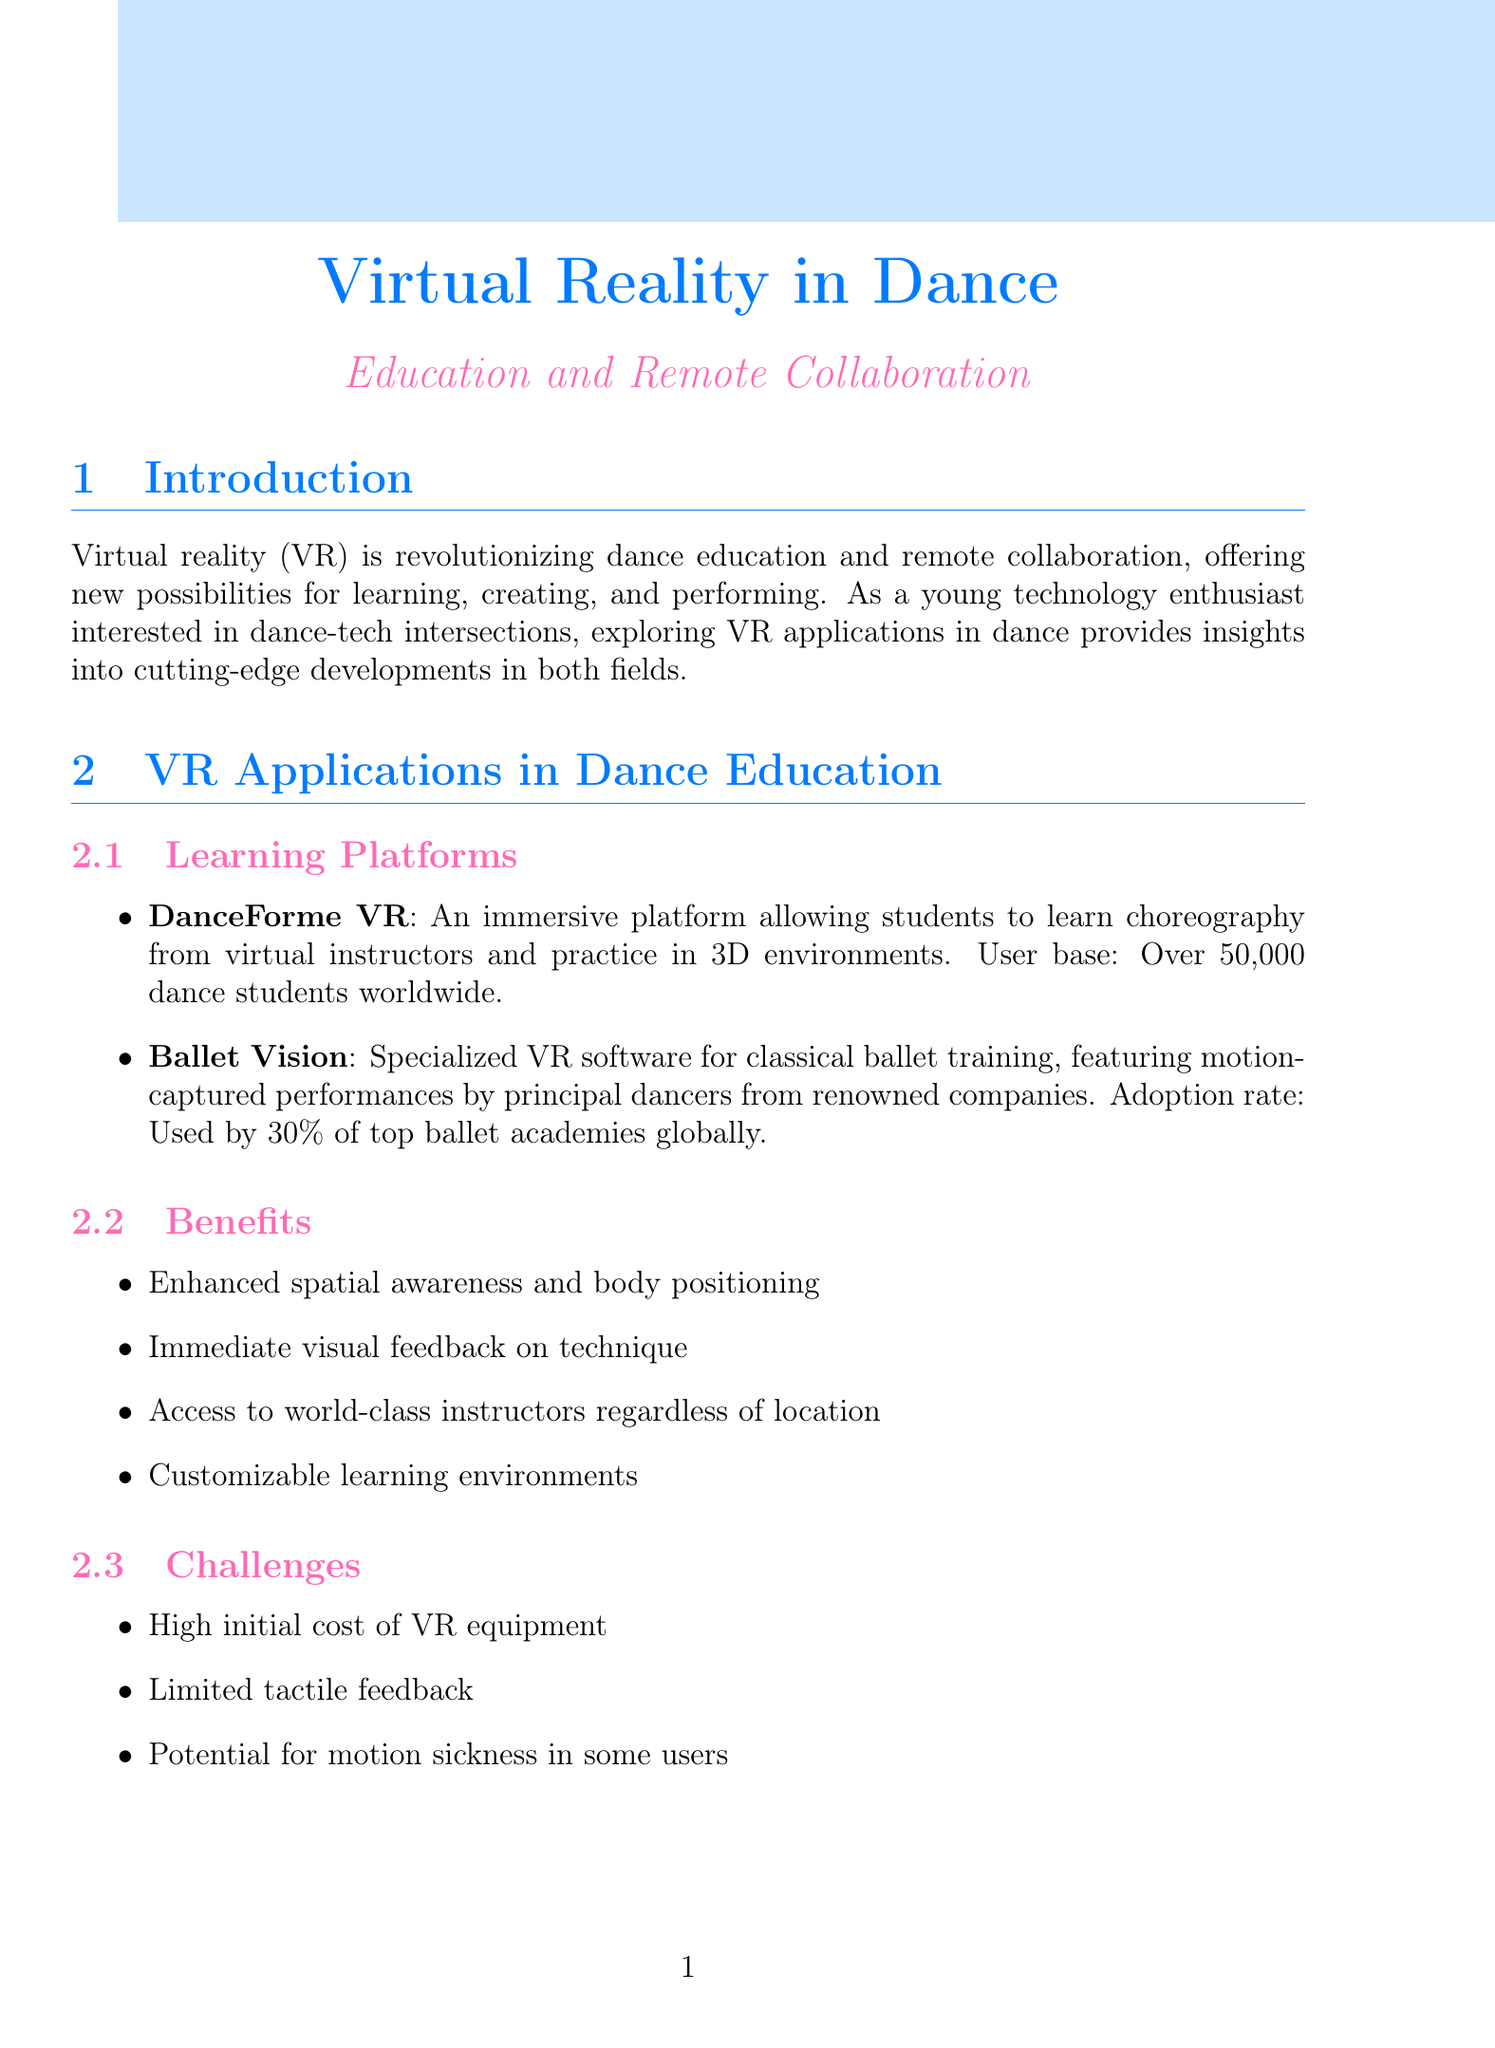What is the projected market value of VR in dance education by 2025? The projected market value represents the expected financial size of the VR in dance education sector, which is $500 million.
Answer: $500 million What percentage of top ballet academies globally use Ballet Vision? This percentage reflects the adoption rate of a specific VR software for ballet training, which is 30%.
Answer: 30% Who reported a 20% improvement in partnering skills? Identifying an individual user experience, this person is Sarah Chen, a ballet dancer.
Answer: Sarah Chen What is the annual growth rate for VR adoption in dance education since 2020? This growth rate indicates the increase in the use of VR technology in dance education, which is 25%.
Answer: 25% What is one of the main challenges associated with using VR in dance education? This challenge reflects a common issue encountered when using VR technology, which is high initial cost of VR equipment.
Answer: High initial cost of VR equipment What percentage of users are between the ages of 18-35? This demographic detail gives insight into the age distribution of users engaged with VR in dance, which is 65%.
Answer: 65% What feature is available in the VirtuDance platform? This feature highlights a capability of the platform designed to enhance collaboration, which is 3D motion tracking.
Answer: 3D motion tracking Which tool is used by 40% of professional contemporary dance companies in North America? This specifies a technology adopted widely among dance companies for planning stages, which is MoveSpace.
Answer: MoveSpace 